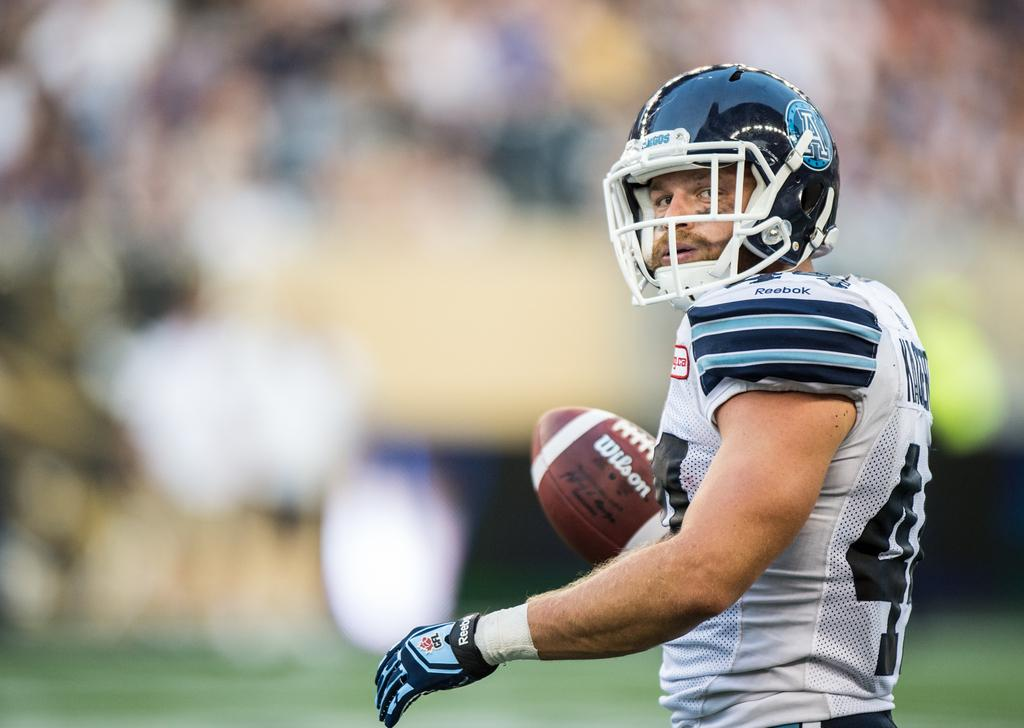What is the main subject in the foreground of the picture? There is a man in the foreground of the picture. What is the man doing in the picture? The man is standing in the picture. What is the man wearing on his head? The man is wearing a helmet in the picture. What object is the man holding in his hand? The man is holding a rugby ball in his hand. How would you describe the background of the image? The background of the image is blurred. How many chess pieces can be seen on the table in the image? There are no chess pieces visible in the image; the man is holding a rugby ball. What type of bubble is floating near the man's head in the image? There is no bubble present in the image; the man is wearing a helmet. 